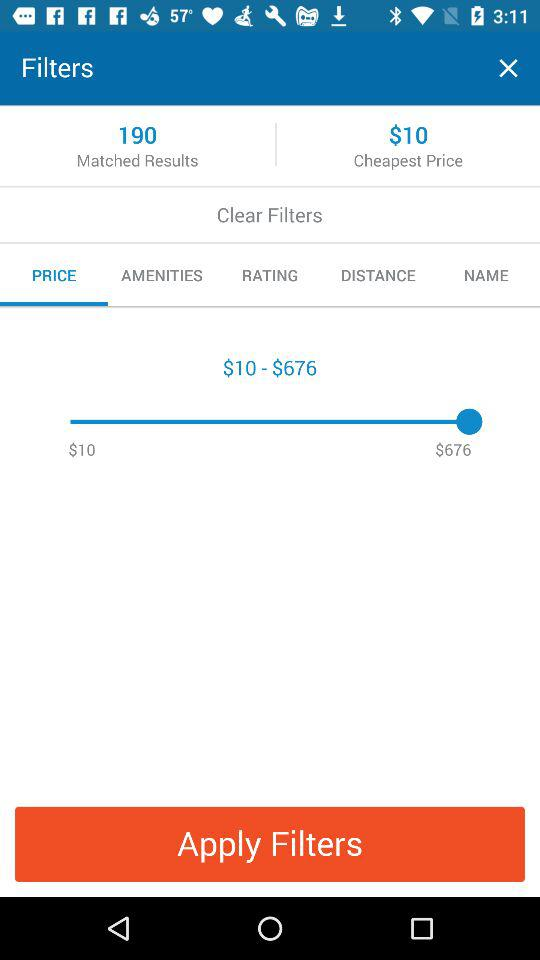What are the matched results? The matched results are 190. 